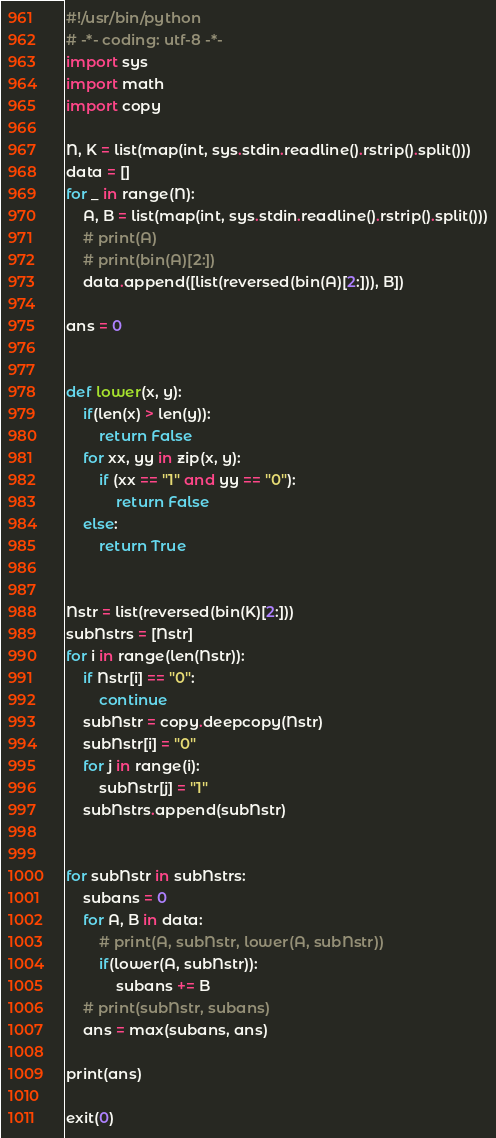Convert code to text. <code><loc_0><loc_0><loc_500><loc_500><_Python_>#!/usr/bin/python
# -*- coding: utf-8 -*-
import sys
import math
import copy

N, K = list(map(int, sys.stdin.readline().rstrip().split()))
data = []
for _ in range(N):
    A, B = list(map(int, sys.stdin.readline().rstrip().split()))
    # print(A)
    # print(bin(A)[2:])
    data.append([list(reversed(bin(A)[2:])), B])

ans = 0


def lower(x, y):
    if(len(x) > len(y)):
        return False
    for xx, yy in zip(x, y):
        if (xx == "1" and yy == "0"):
            return False
    else:
        return True


Nstr = list(reversed(bin(K)[2:]))
subNstrs = [Nstr]
for i in range(len(Nstr)):
    if Nstr[i] == "0":
        continue
    subNstr = copy.deepcopy(Nstr)
    subNstr[i] = "0"
    for j in range(i):
        subNstr[j] = "1"
    subNstrs.append(subNstr)


for subNstr in subNstrs:
    subans = 0
    for A, B in data:
        # print(A, subNstr, lower(A, subNstr))
        if(lower(A, subNstr)):
            subans += B
    # print(subNstr, subans)
    ans = max(subans, ans)

print(ans)

exit(0)
</code> 